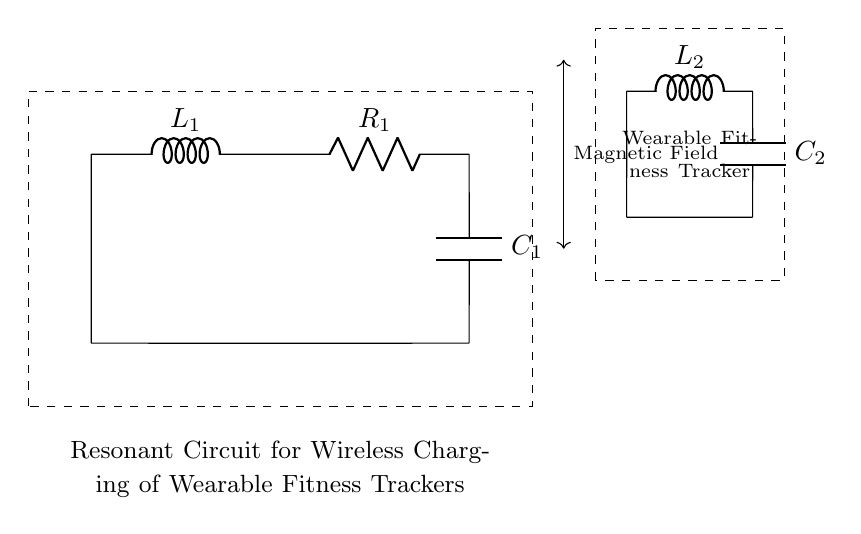What is the type of the circuit shown? The circuit contains inductors, capacitors, and a resistor, which defines it as an RLC circuit.
Answer: RLC circuit How many inductors are present in the circuit? Upon examination of the diagram, there are two distinct inductors labeled L1 and L2.
Answer: 2 What is the value of the first capacitor labeled in the circuit? The first capacitor in the diagram is labeled C1, but without specific values shown, we can only refer to it by its label.
Answer: C1 What does the dashed rectangle indicate in the circuit? The dashed rectangle highlights the section of the circuit, which is specifically identified as the resonant circuit for wireless charging of wearable fitness trackers.
Answer: Resonant circuit How do the components L2 and C2 relate to the wearable fitness tracker? L2 and C2 are part of the circuit connected to the wearable fitness tracker, indicating they are involved in its wireless charging process by forming another resonant circuit.
Answer: Wireless charging circuit What is the primary function of the inductor in this circuit? The inductor serves to store energy in a magnetic field, an essential function for resonant circuits like this which are used for efficient power transfer in wireless charging applications.
Answer: Energy storage In which part of the circuit can you find the resistor? The resistor labeled R1 is placed between the first inductor L1 and the first capacitor C1, indicating it is an essential component for controlling the circuit's behavior.
Answer: Between L1 and C1 